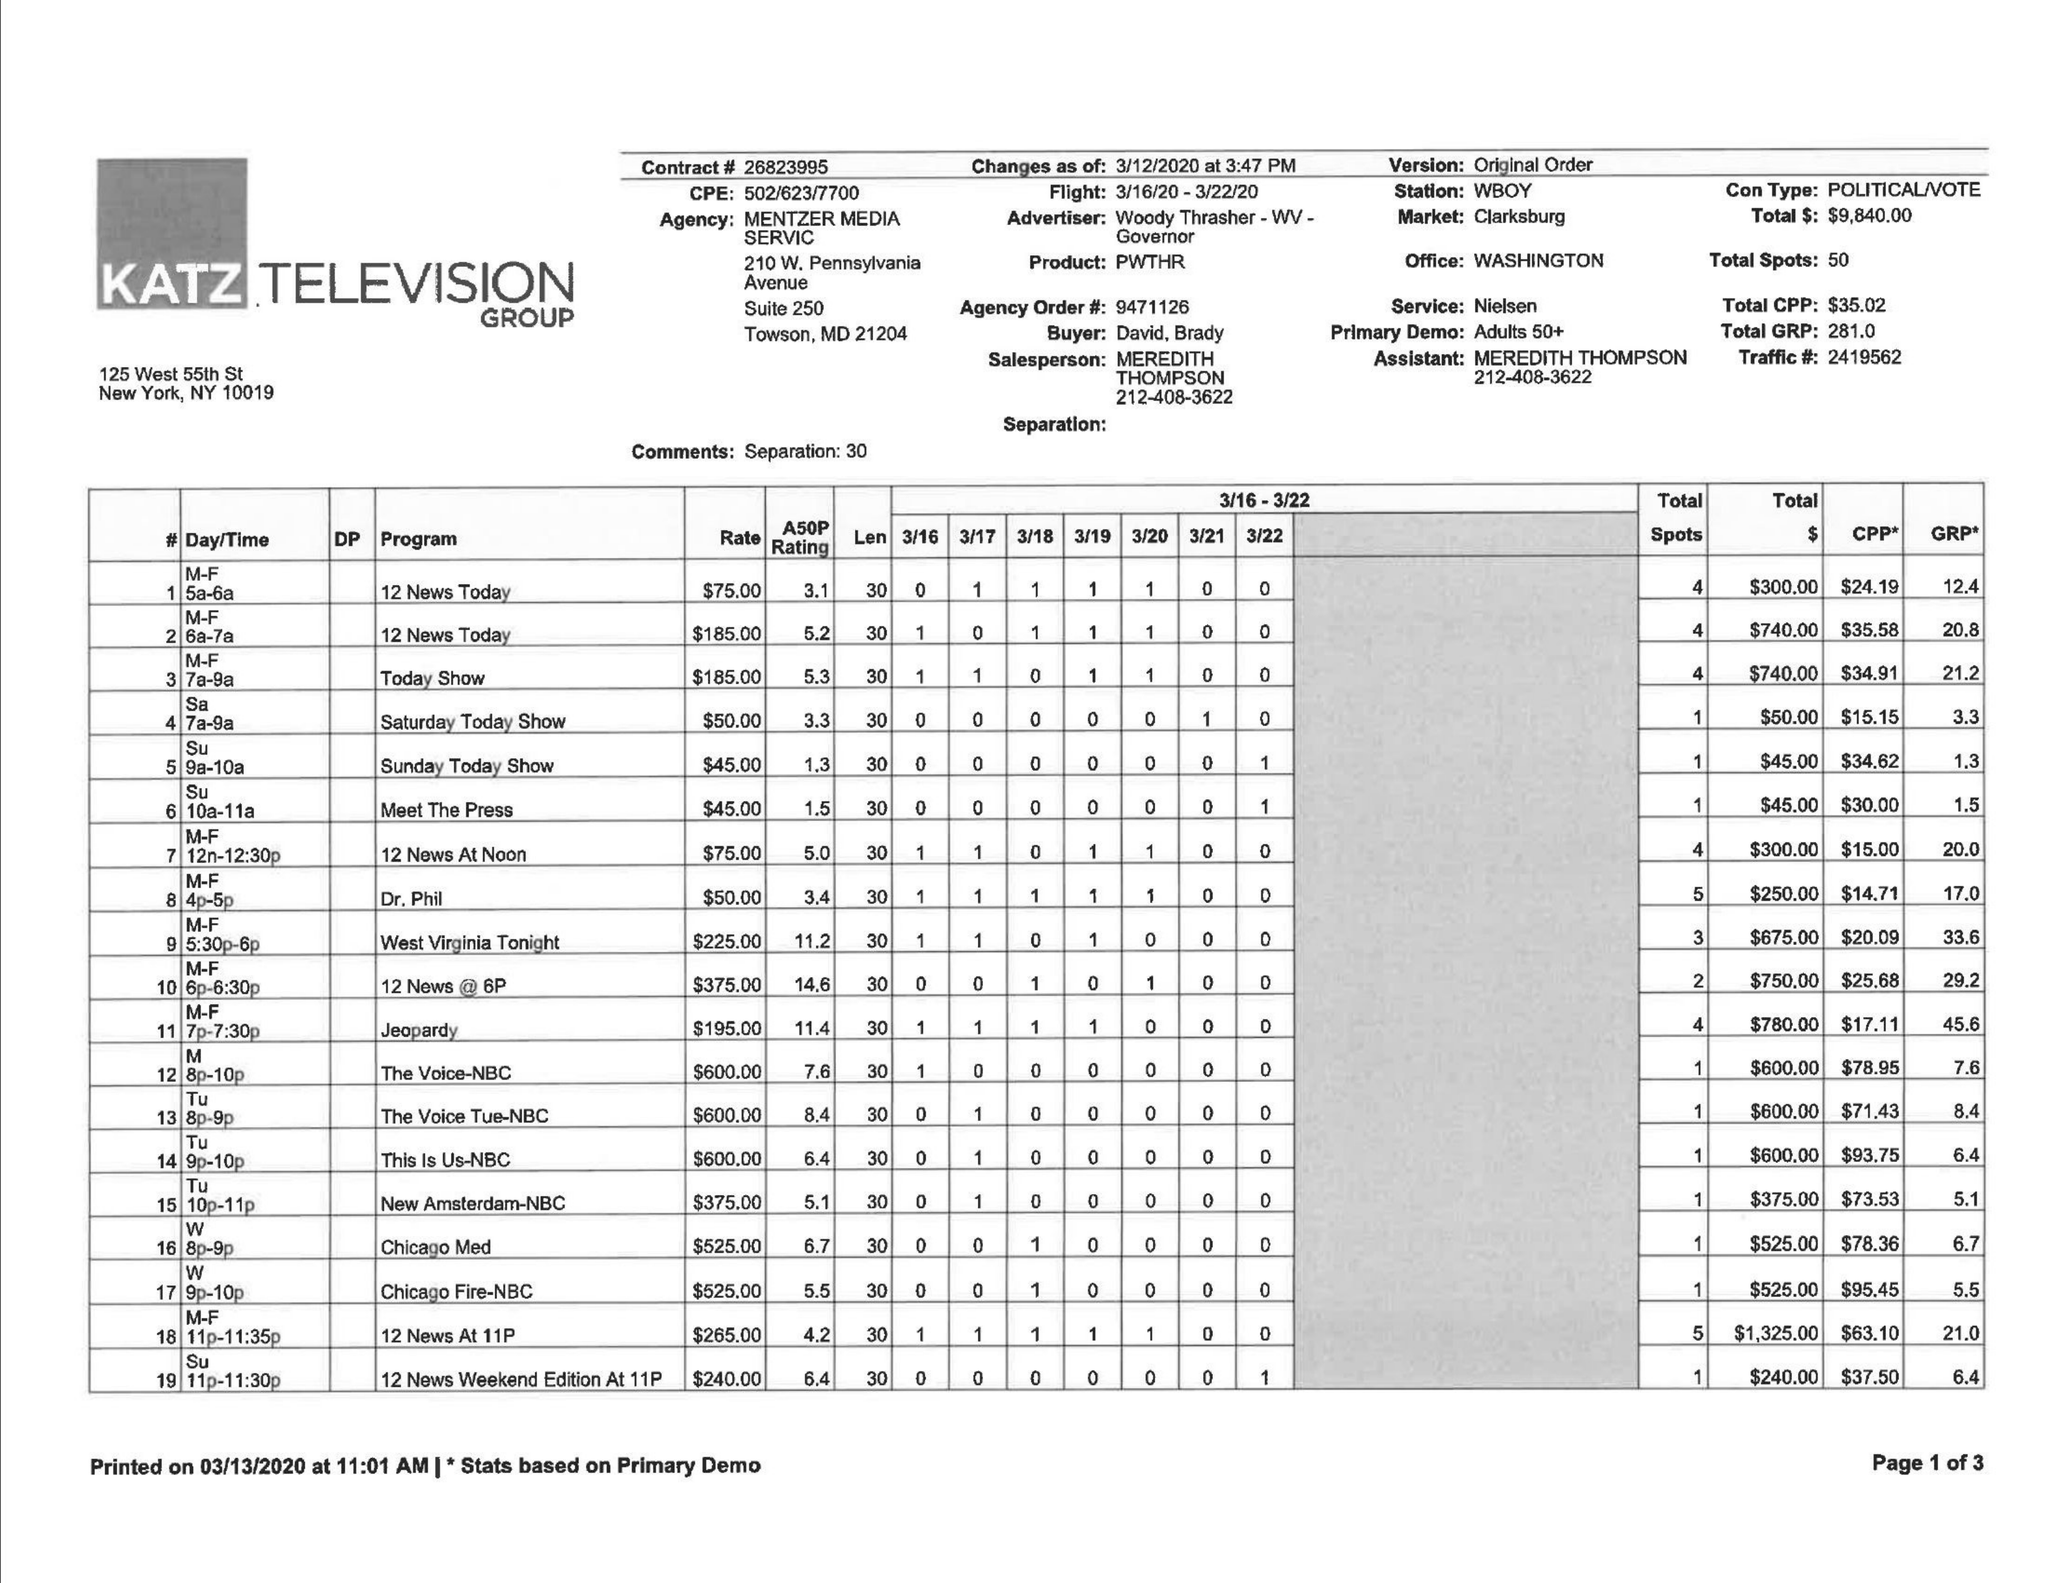What is the value for the gross_amount?
Answer the question using a single word or phrase. 9840.00 